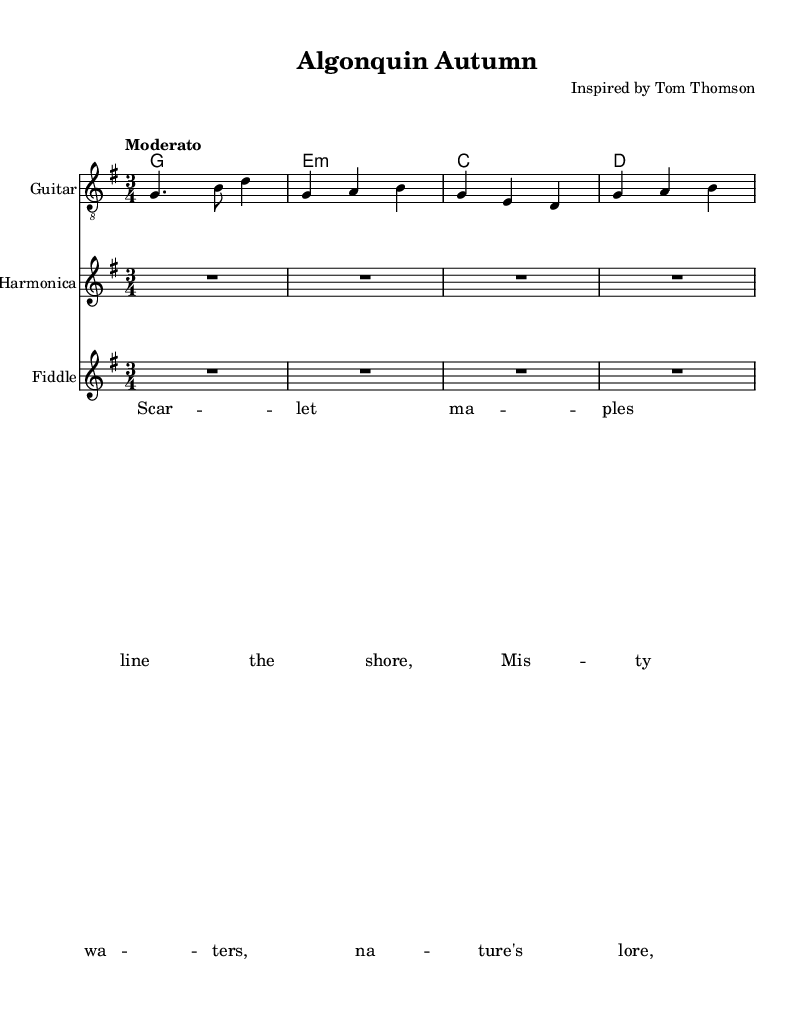What is the title of this piece? The title of the piece is listed at the top under the header section. It is "Algonquin Autumn".
Answer: Algonquin Autumn What is the key signature? The key signature indicates the key in which the piece is composed. In this score, it shows one sharp (F#), which corresponds to G major.
Answer: G major What is the time signature? The time signature, found in the beginning of the piece, is shown as "3/4". This means there are three beats per measure, and the quarter note gets one beat.
Answer: 3/4 What is the tempo indication? The tempo is indicated above the staff by the word "Moderato", suggesting a moderate pace for the music.
Answer: Moderato How many measures are in the melody? The melody has 8 measures in total, as counted from the music notation. Each line typically represents 4 measures, and there are 2 lines.
Answer: 8 Which instrument has the lyrics aligned above it? The lyrics are aligned above the "Guitar" staff according to the layout instructions in the score.
Answer: Guitar What is the first line of the lyrics? The first line of the lyrics is "Scar -- let ma -- ples line the shore," which is stated in the lyric mode section.
Answer: Scar -- let ma -- ples line the shore 